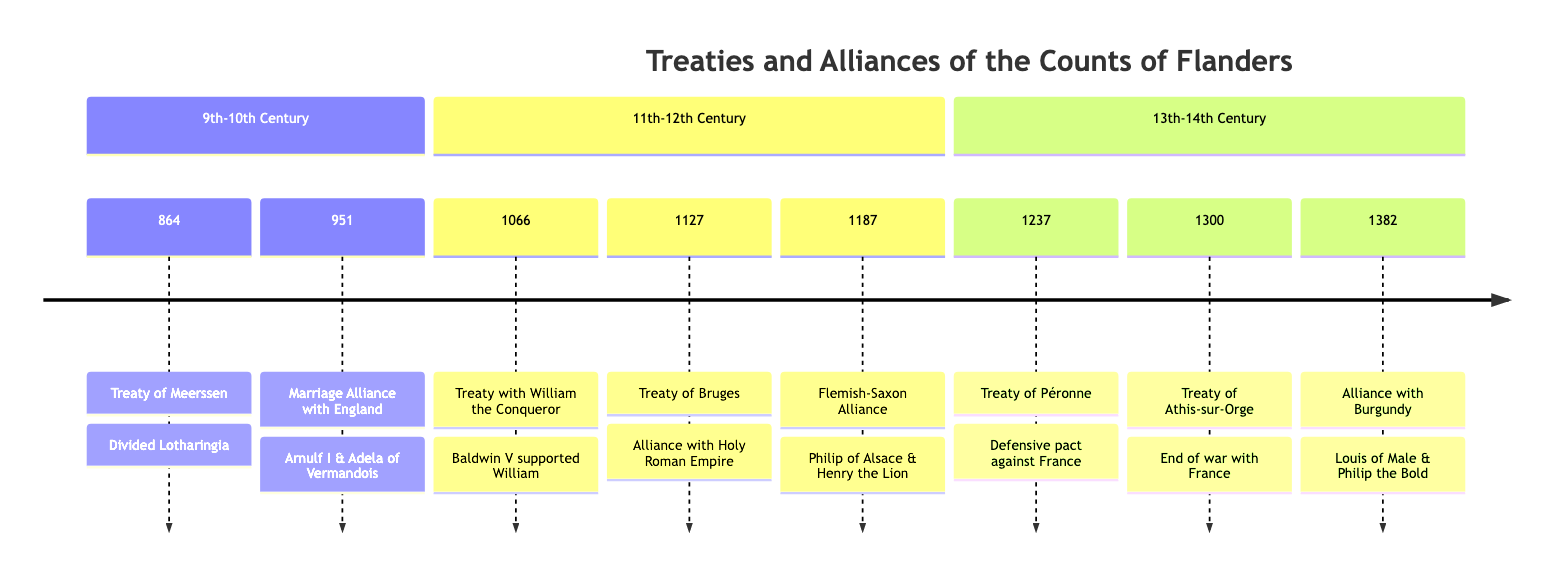What year was the Treaty of Bruges signed? The diagram shows the Treaty of Bruges under the section for the 11th-12th century, with the year indicated as 1127.
Answer: 1127 What event is associated with the year 1382? According to the timeline, the year 1382 features the event "Alliance with the Duchy of Burgundy."
Answer: Alliance with the Duchy of Burgundy How many sections are in the timeline? By evaluating the diagram, it can be seen that there are three distinct sections: 9th-10th Century, 11th-12th Century, and 13th-14th Century.
Answer: 3 Which treaty formed a defensive pact against France? The timeline indicates that the Treaty of Péronne was specifically created as a defensive pact against French aggression in 1237.
Answer: Treaty of Péronne Who was Count Guy’s counterpart in the Treaty of Athis-sur-Orge? The diagram states that Count Guy of Dampierre signed the Treaty of Athis-sur-Orge with Philip IV of France.
Answer: Philip IV of France What was the significance of the Treaty of Meerssen in regional politics? The details provided in the timeline emphasize that the Treaty of Meerssen shifted regional power dynamics and influenced Flanders' future alliances.
Answer: Shifted regional power dynamics Which two leaders were involved in the Flemish-Saxon Alliance? The timeline indicates that Philip of Alsace, Count of Flanders, and Henry the Lion, Duke of Saxony, were key figures in forming the Flemish-Saxon Alliance in 1187.
Answer: Philip of Alsace and Henry the Lion What was the outcome of the 1300 Treaty of Athis-sur-Orge? The diagram explains that the Treaty of Athis-sur-Orge effectively ended the war over Flemish control and autonomy, leading to a temporary stabilization.
Answer: Ended the war over Flemish control What event marks the earliest treaty in the timeline? The earliest treaty listed in the timeline is the Treaty of Meerssen, which took place in 864, clearly indicating it as the first event.
Answer: Treaty of Meerssen 